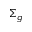<formula> <loc_0><loc_0><loc_500><loc_500>\Sigma _ { g }</formula> 